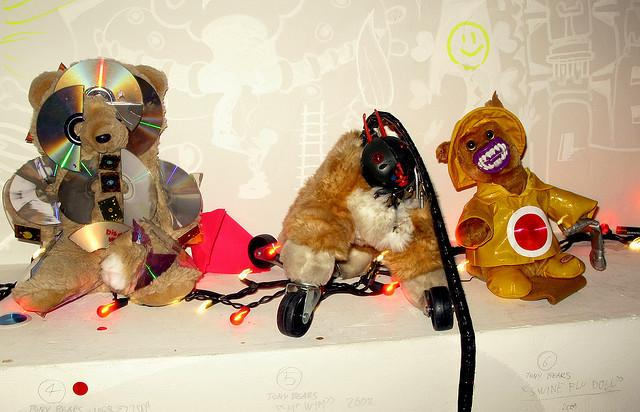What are the shattered items on the bear?

Choices:
A) cassettes
B) 8-tracks
C) cds
D) records cds 